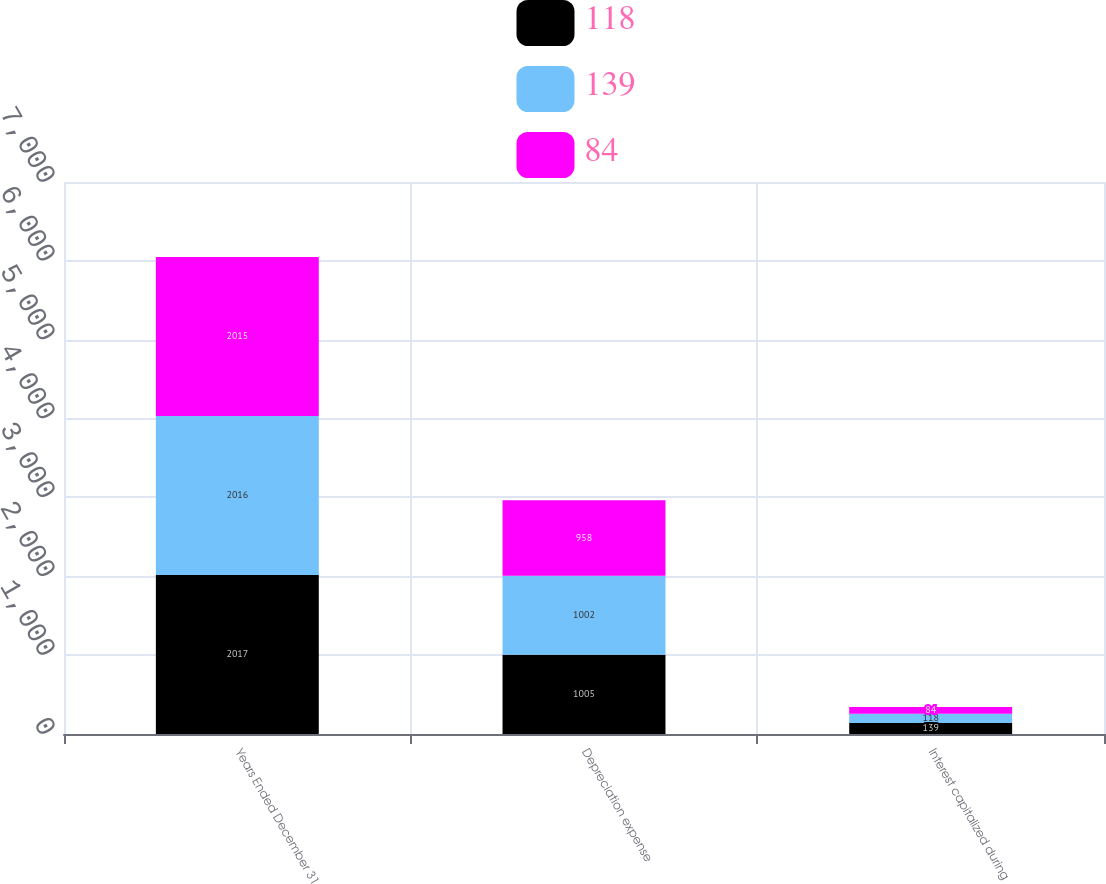Convert chart to OTSL. <chart><loc_0><loc_0><loc_500><loc_500><stacked_bar_chart><ecel><fcel>Years Ended December 31<fcel>Depreciation expense<fcel>Interest capitalized during<nl><fcel>118<fcel>2017<fcel>1005<fcel>139<nl><fcel>139<fcel>2016<fcel>1002<fcel>118<nl><fcel>84<fcel>2015<fcel>958<fcel>84<nl></chart> 